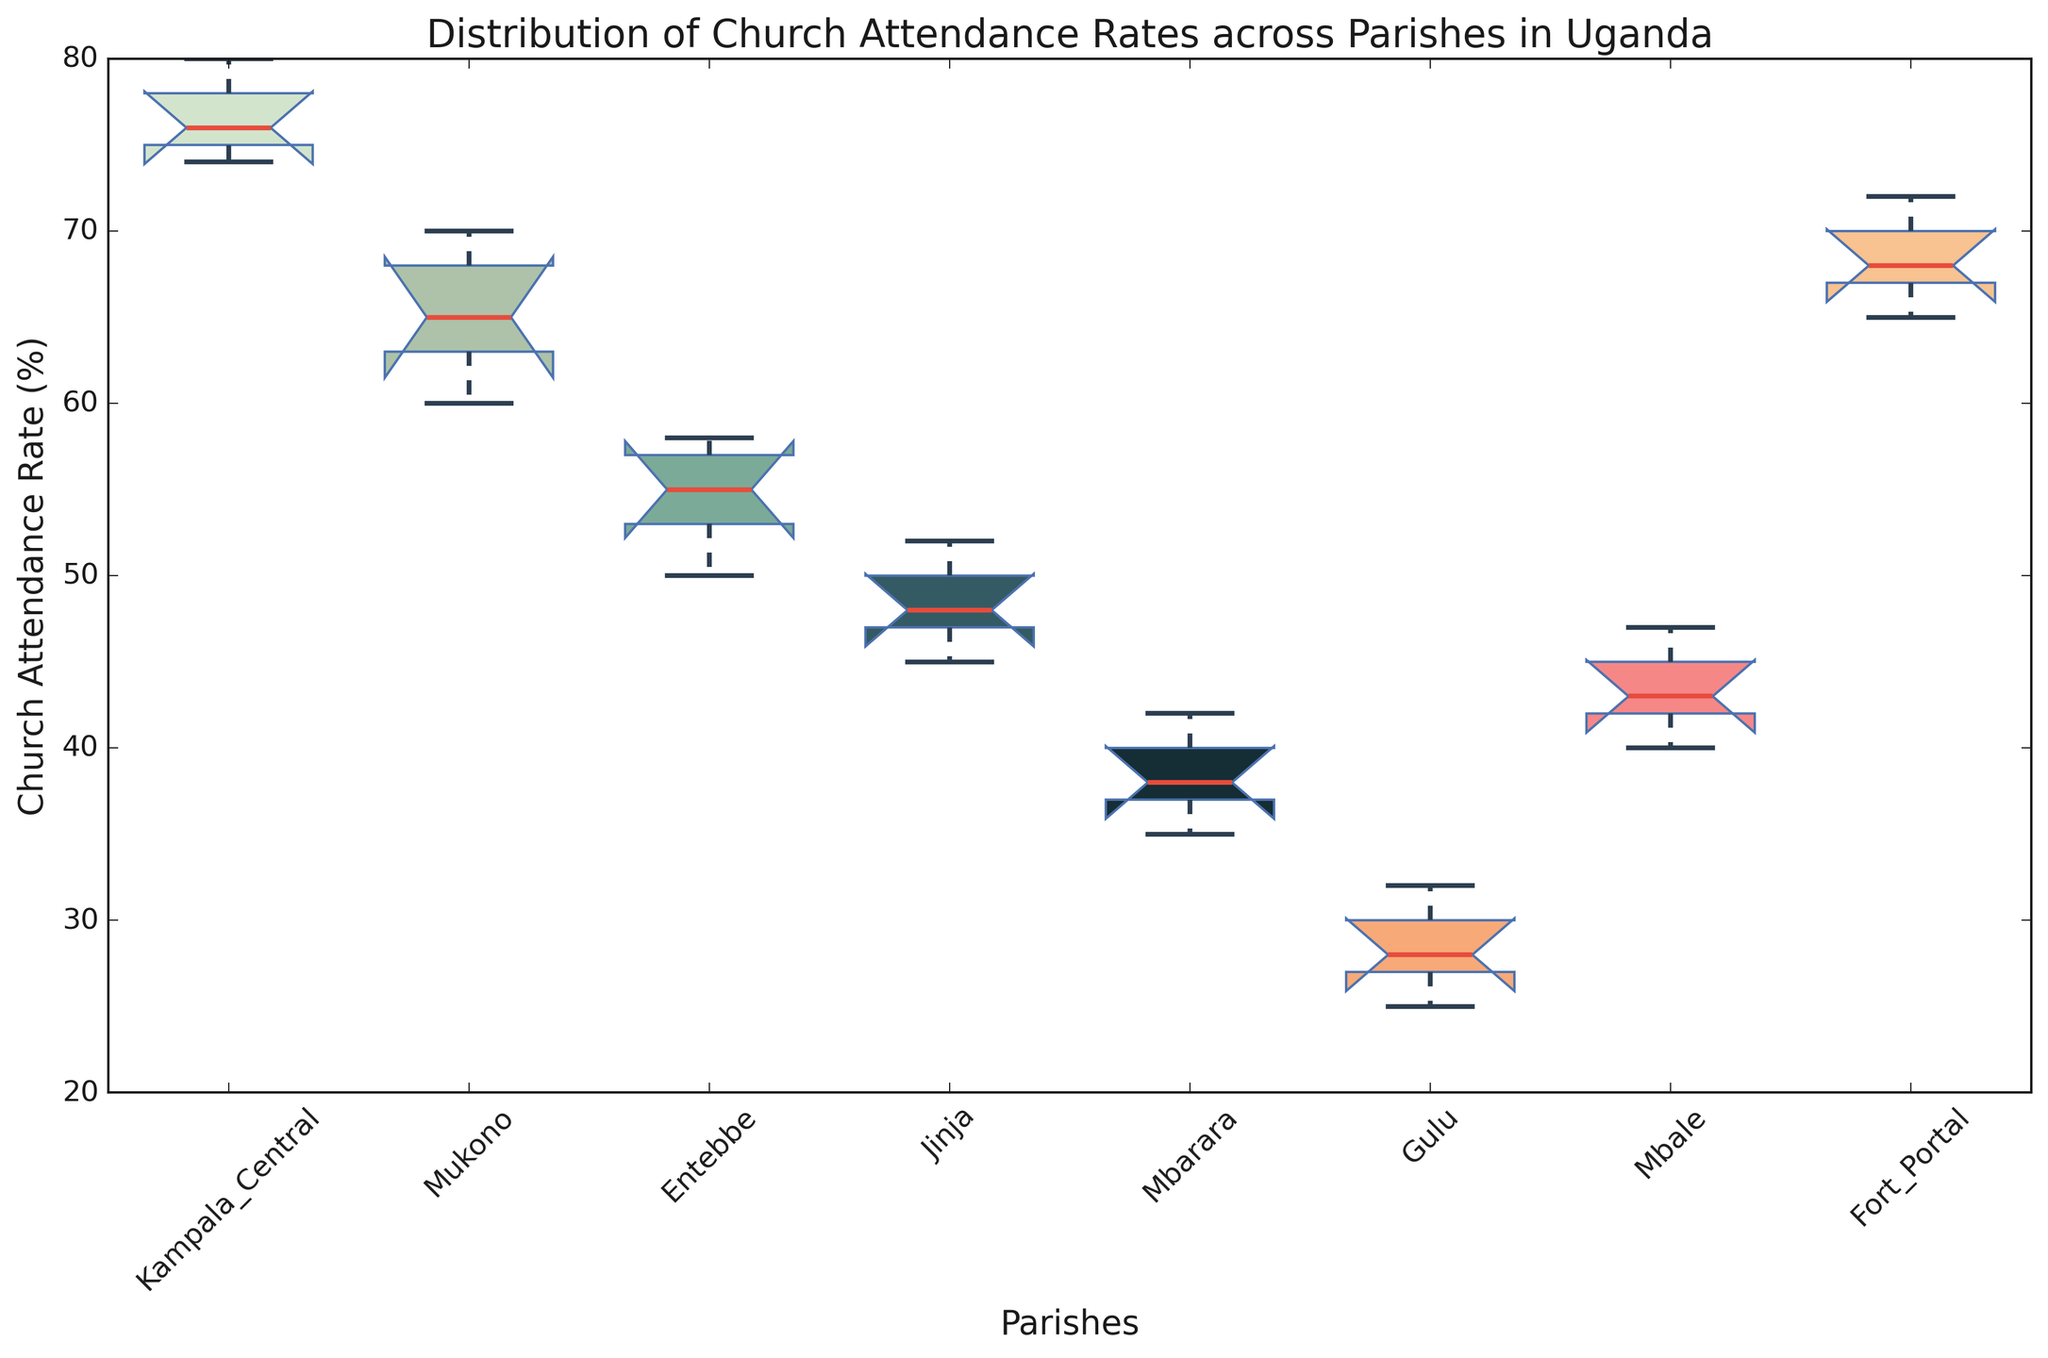What’s the median church attendance rate for Kampala Central parish? The box plot displays the median as the horizontal line within the box. For Kampala Central, this line is positioned around 76.
Answer: 76 Which parish has the highest median church attendance rate? To determine this, look at the median lines within each box plot and identify the highest positioned one. Fort Portal has the highest median, which appears to be around 68.
Answer: Fort Portal Compare the interquartile range (IQR) of Mukono and Jinja parishes. Which one is larger? The IQR is represented by the length of the box (from the first quartile to the third quartile). Mukono's box is larger compared to Jinja's, indicating a larger IQR.
Answer: Mukono What is the highest recorded church attendance rate among all parishes? The highest value is depicted by the top whisker or outlier point of the box plots. Kampala Central has the highest point, which is around 80.
Answer: 80 Which parish has the lowest variation in church attendance rates? The parish with the smallest box (smallest IQR) typically has the lowest variation. The box for Mbarara is the smallest, indicating the lowest variation.
Answer: Mbarara What is the difference between the medians of Entebbe and Jinja parishes? The median of Entebbe is around 53, and Jinja’s is around 48, so the difference is 5.
Answer: 5 Which parishes have outliers? Outliers are indicated by points outside the whiskers of the box plots. No parishes have clear outliers outside the whiskers in this plot.
Answer: None How does the median church attendance rate for Fort Portal compare to the third quartile rate of Entebbe? The median of Fort Portal (around 68) is higher than the third quartile (top edge of the box) of Entebbe which is approximately 58.
Answer: Fort Portal's median is higher 